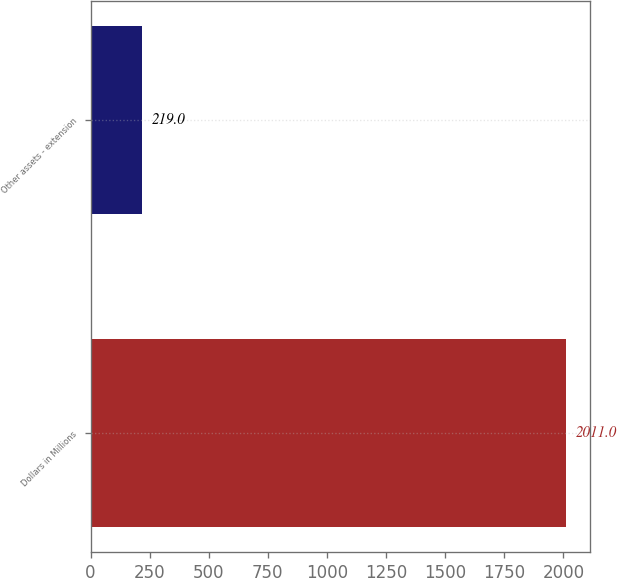Convert chart. <chart><loc_0><loc_0><loc_500><loc_500><bar_chart><fcel>Dollars in Millions<fcel>Other assets - extension<nl><fcel>2011<fcel>219<nl></chart> 